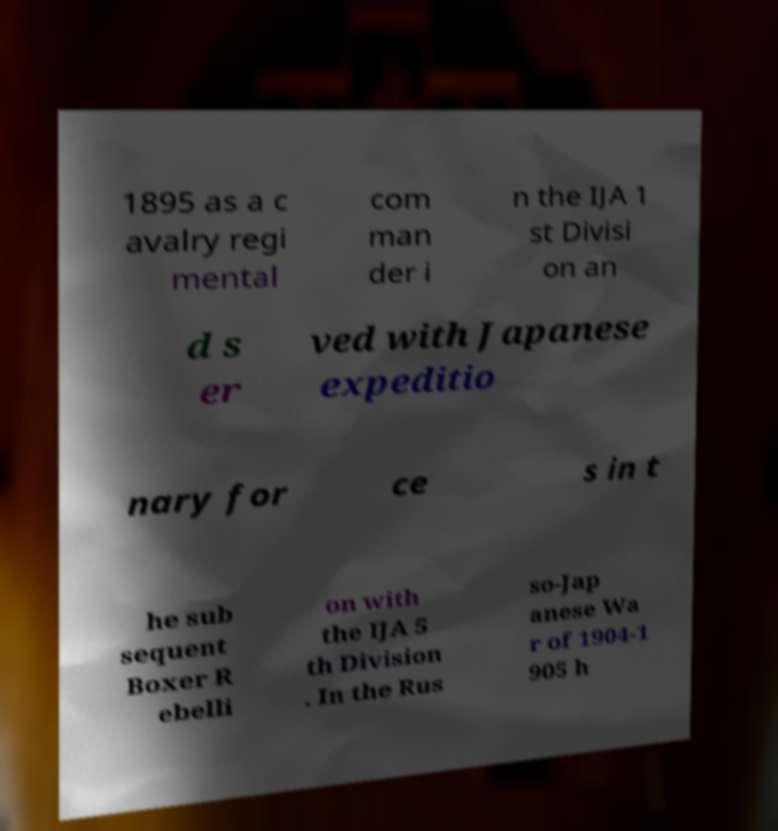Can you accurately transcribe the text from the provided image for me? 1895 as a c avalry regi mental com man der i n the IJA 1 st Divisi on an d s er ved with Japanese expeditio nary for ce s in t he sub sequent Boxer R ebelli on with the IJA 5 th Division . In the Rus so-Jap anese Wa r of 1904-1 905 h 